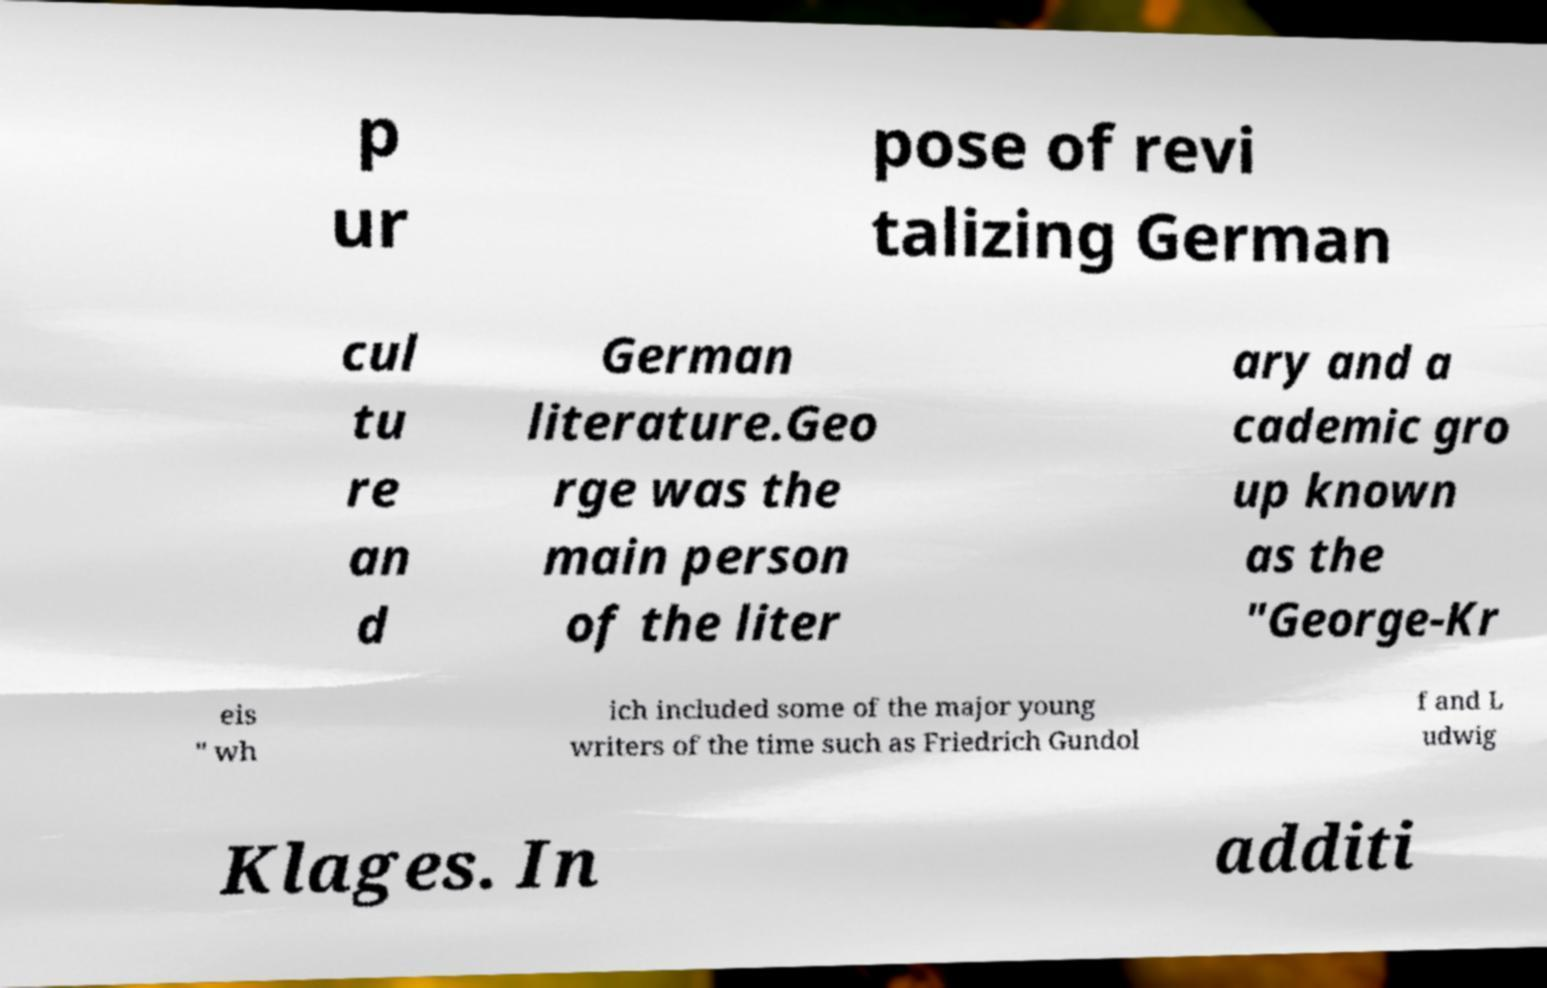Can you accurately transcribe the text from the provided image for me? p ur pose of revi talizing German cul tu re an d German literature.Geo rge was the main person of the liter ary and a cademic gro up known as the "George-Kr eis " wh ich included some of the major young writers of the time such as Friedrich Gundol f and L udwig Klages. In additi 